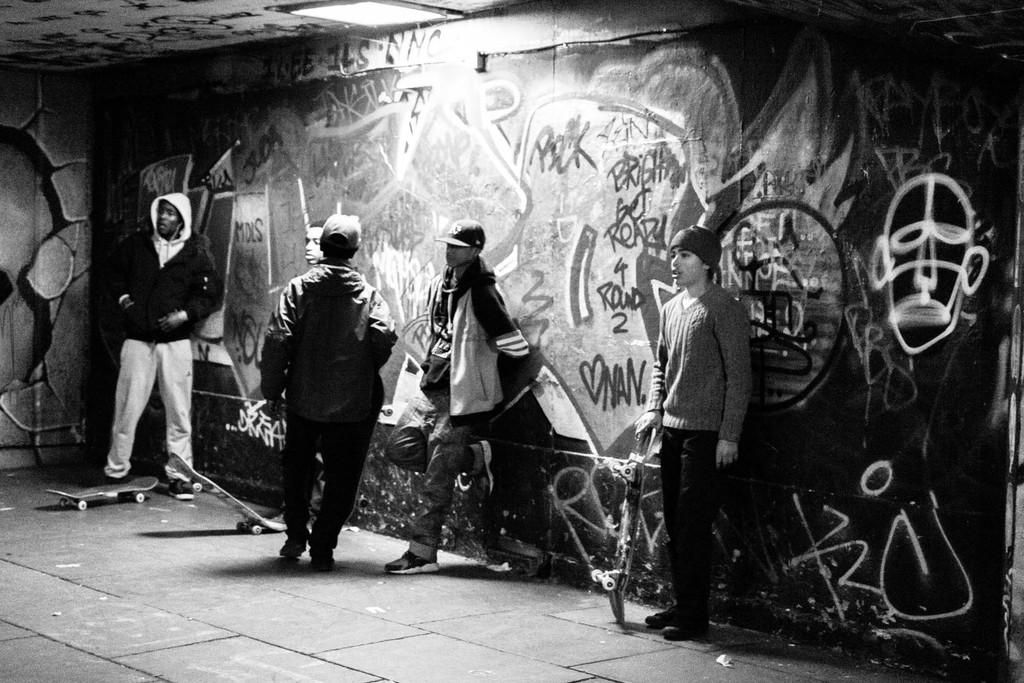How many people are in the image? There is a group of persons in the image. What are some of the persons holding? Some of the persons are holding skateboards. What are the persons doing in the image? The persons are leaning against a wall. What can be seen on the wall? There are paintings and words written on the wall. What is the chin of the person holding the skateboard doing in the image? There is no chin or specific person mentioned in the image; it only states that some persons are holding skateboards. 